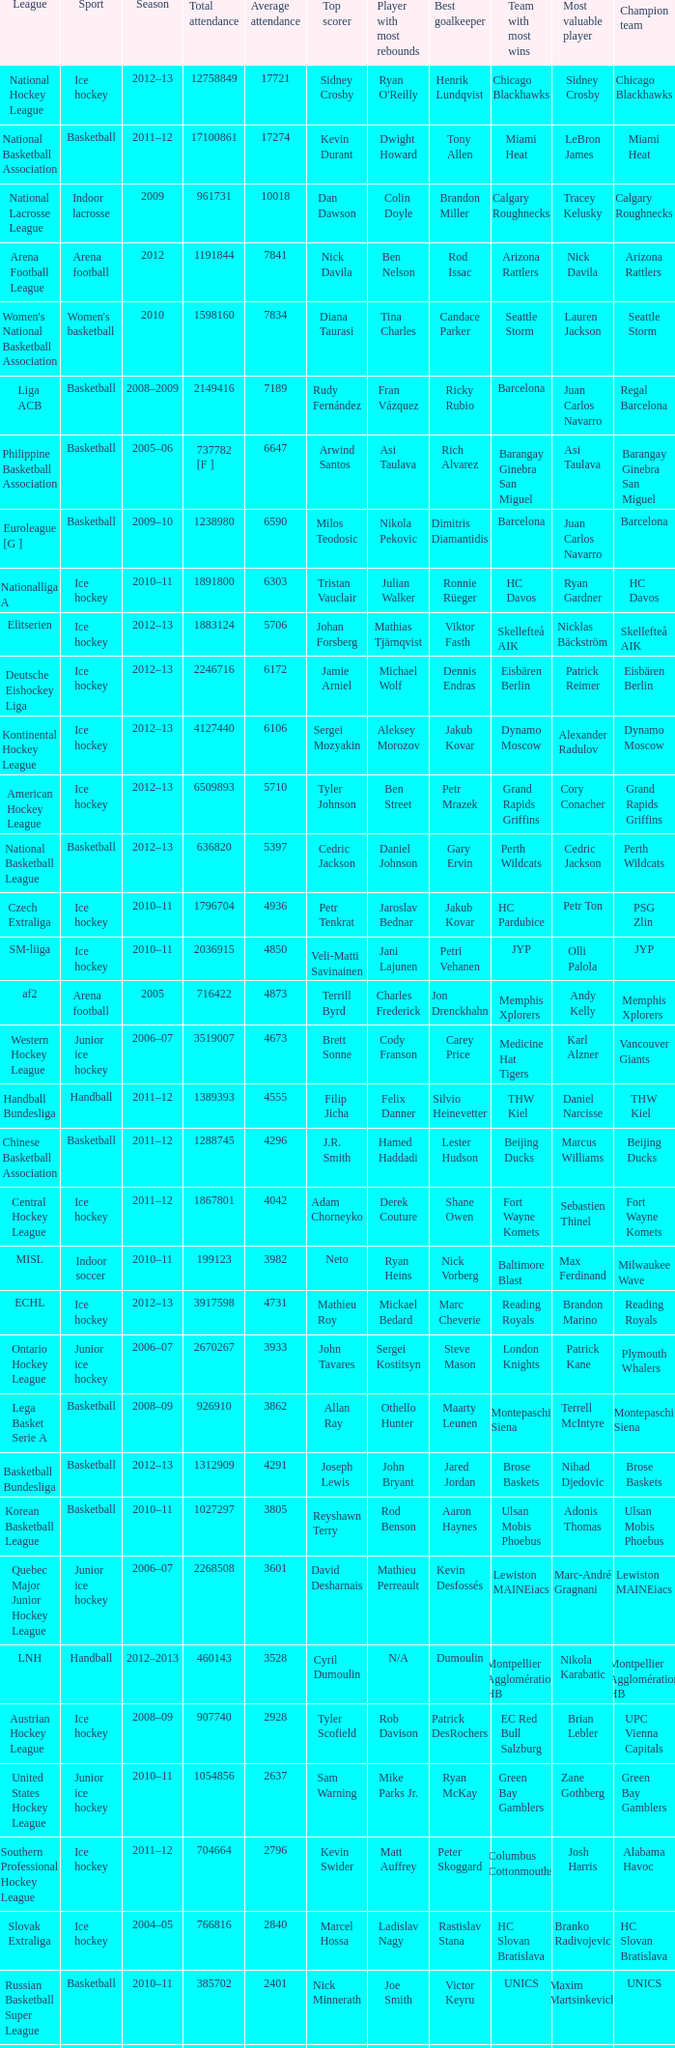What's the average attendance of the league with a total attendance of 2268508? 3601.0. 